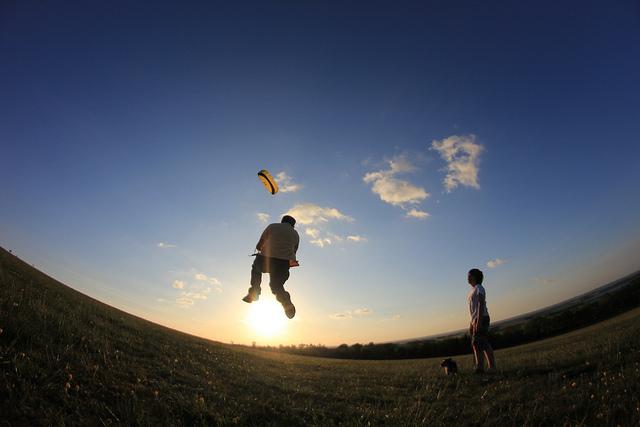Are there clouds visible?
Concise answer only. Yes. Is there a shadow in the pic?
Answer briefly. No. What is in the air?
Short answer required. Kite. What is the boy jumping over?
Be succinct. Grass. Sunny or overcast?
Answer briefly. Sunny. Is there a kite in the sky?
Short answer required. Yes. What is this person doing?
Write a very short answer. Flying kite. 